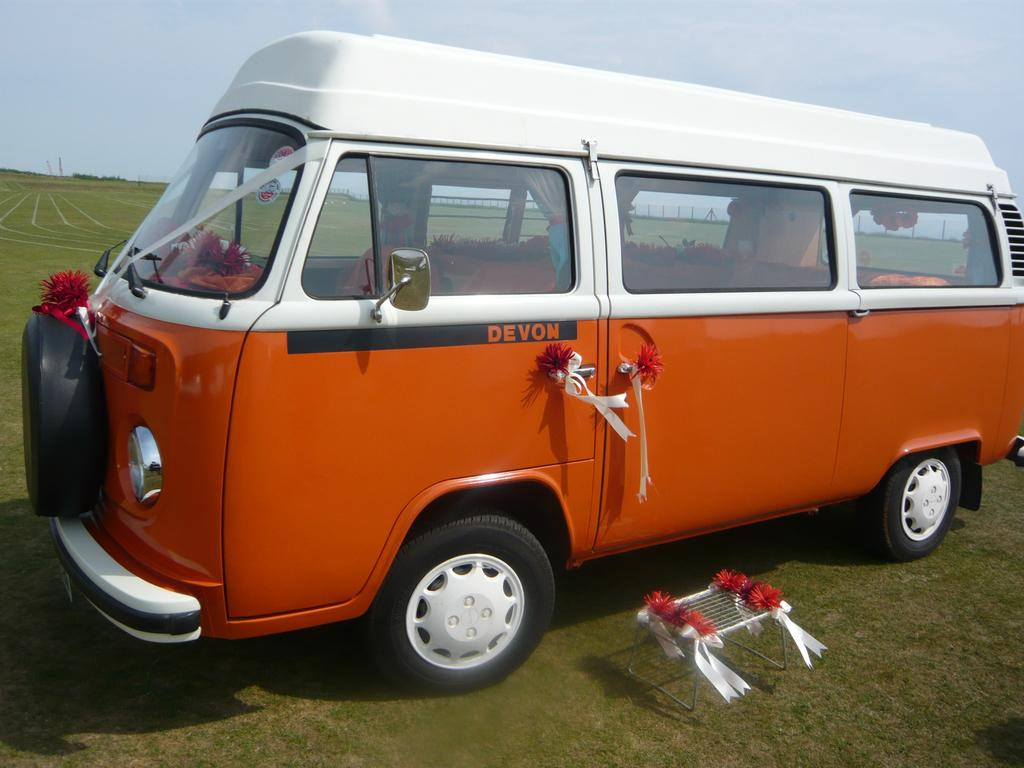<image>
Summarize the visual content of the image. The orange and white van has Devon written on the door. 